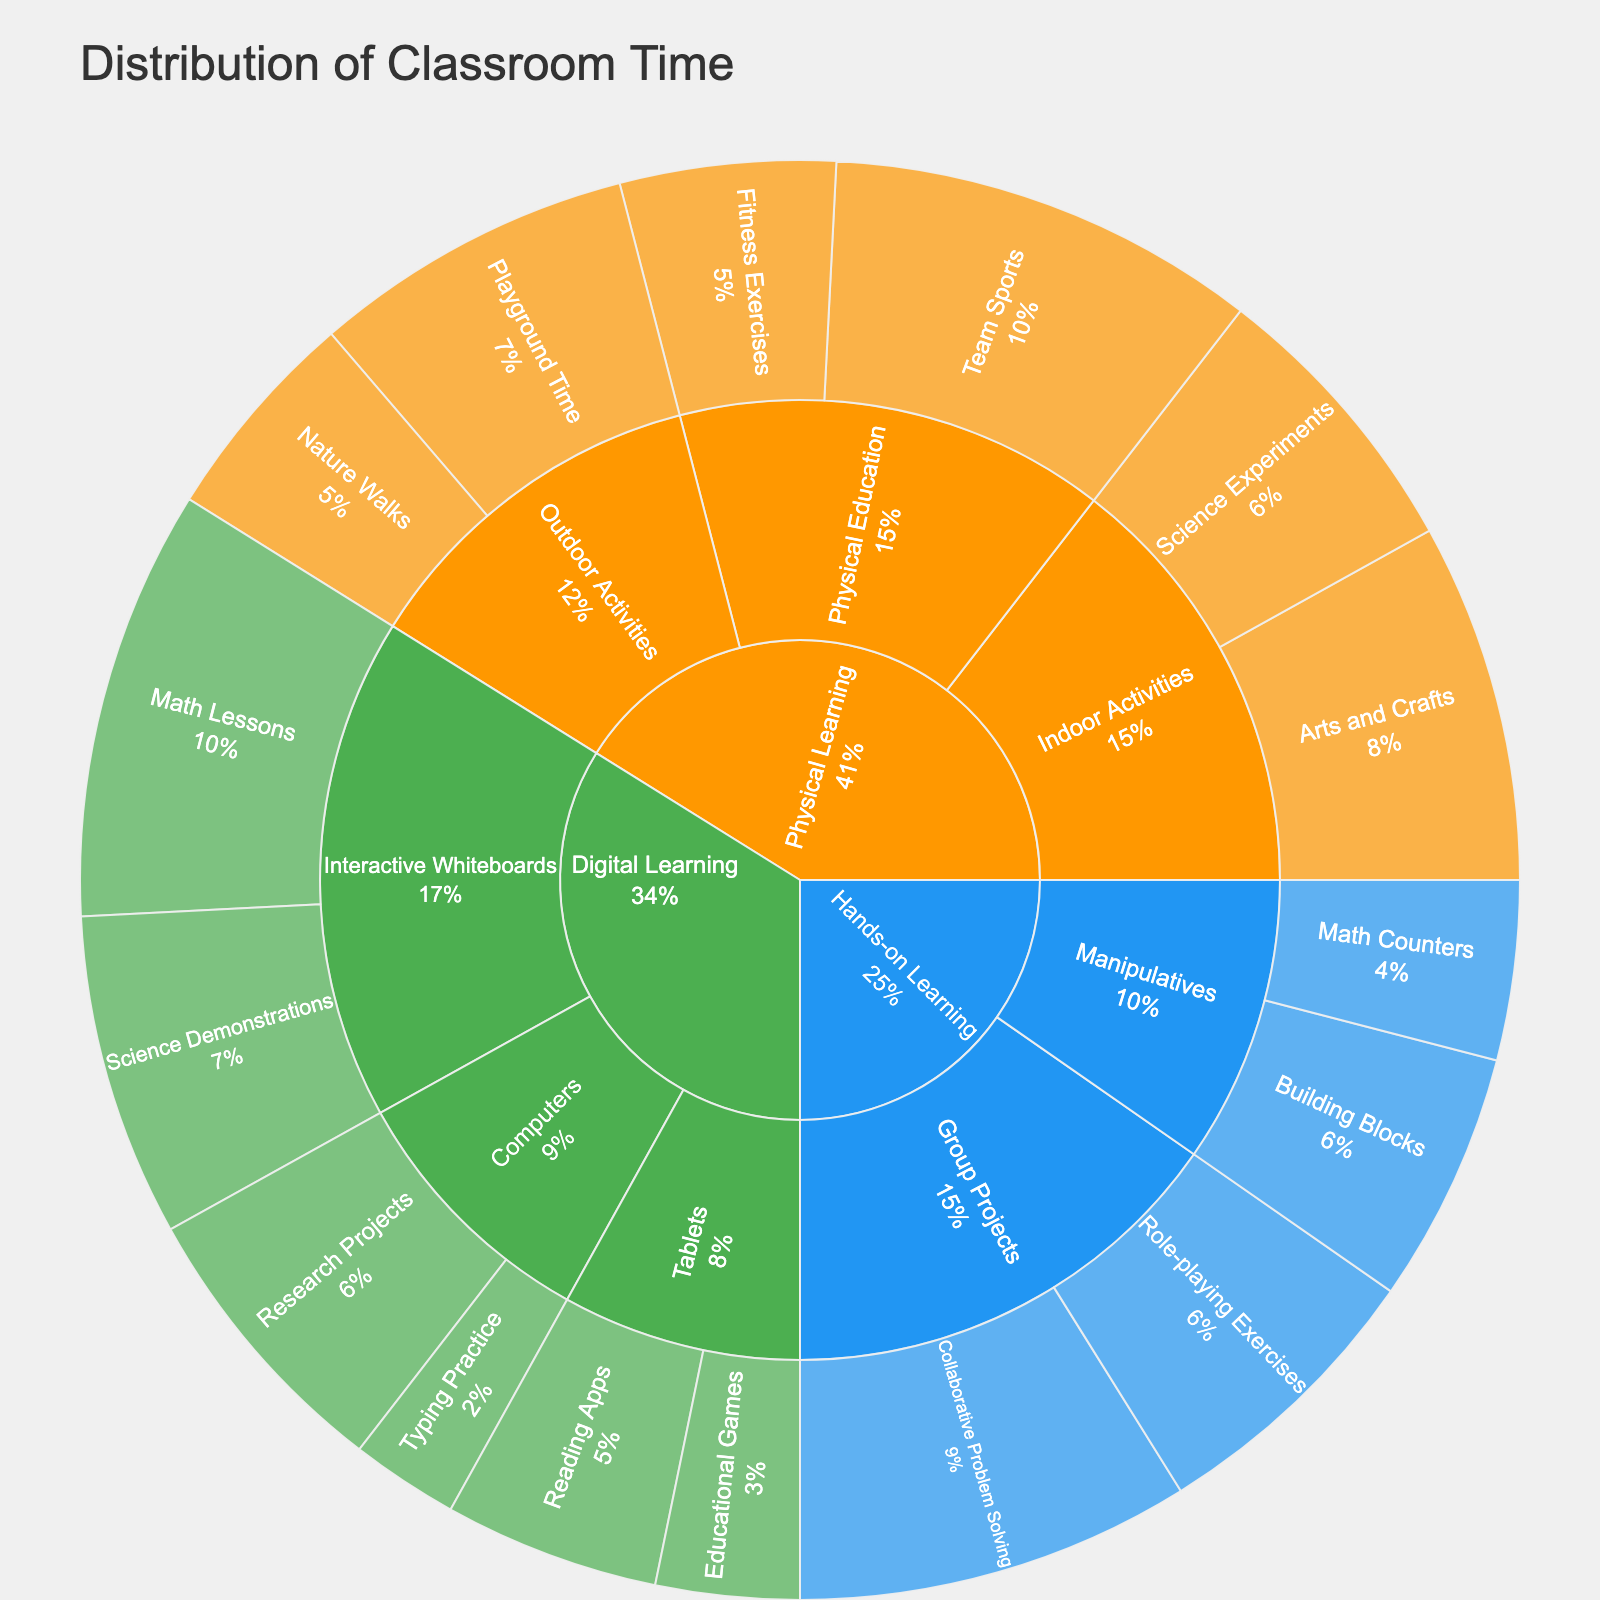What category has the most total classroom time? First, identify the three main categories: Digital Learning, Physical Learning, and Hands-on Learning. From the visual, sum up the time spent in each category. Compare the totals to find the category with the maximum time.
Answer: Physical Learning How many minutes are spent on Science Demonstrations using Interactive Whiteboards? Identify the Digital Learning category, then zoom in on Interactive Whiteboards, and look for Science Demonstrations to find the time spent.
Answer: 45 Which digital activity has the least time spent? Focus on the Digital Learning category, then compare the time spent on Interactive Whiteboards, Tablets, and Computers activities. The lowest time is for Typing Practice.
Answer: Typing Practice (15 minutes) What is the total time spent on Physical Learning activities? Identify all subcategories under Physical Learning (Outdoor Activities, Indoor Activities, Physical Education). Sum the times of Nature Walks, Playground Time, Arts and Crafts, Science Experiments, Team Sports, and Fitness Exercises.
Answer: 255 minutes Which subcategory in Physical Learning spends the most time? Identify the three subcategories under Physical Learning: Outdoor Activities, Indoor Activities, and Physical Education. Sum the times within each subcategory and compare them.
Answer: Physical Education What is the average time spent on activities under Digital Learning? List the times for all subcategories and activities under Digital Learning (60, 45, 30, 20, 40, 15), sum them up, and divide by the number of activities: (60 + 45 + 30 + 20 + 40 + 15) / 6.
Answer: 35 minutes Between Math Lessons and Math Counters, which has more time allocated? Locate Math Lessons in Digital Learning (60 minutes) and Math Counters in Hands-on Learning (25 minutes), and compare their times.
Answer: Math Lessons (60 minutes) Which activity in Hands-on Learning has the most time spent? Within Hands-on Learning, look at Manipulatives and Group Projects. Compare the individual times (Math Counters, Building Blocks, Collaborative Problem Solving, Role-playing Exercises).
Answer: Collaborative Problem Solving (55 minutes) What is the difference in time spent between Outdoor and Indoor Activities in Physical Learning? Identify the times for Outdoor Activities (Nature Walks 30, Playground Time 45) and Indoor Activities (Arts and Crafts 50, Science Experiments 40). Sum the times for each and find their difference: (30 + 45) - (50 + 40).
Answer: -15 minutes (15 minutes more in Indoor Activities) What percentage of total classroom time is spent on Fitness Exercises? Sum the total times for all activities. Find the time spent on Fitness Exercises. Calculate the percentage: (30 minutes for Fitness Exercises / total time) * 100.
Answer: 6.5% 